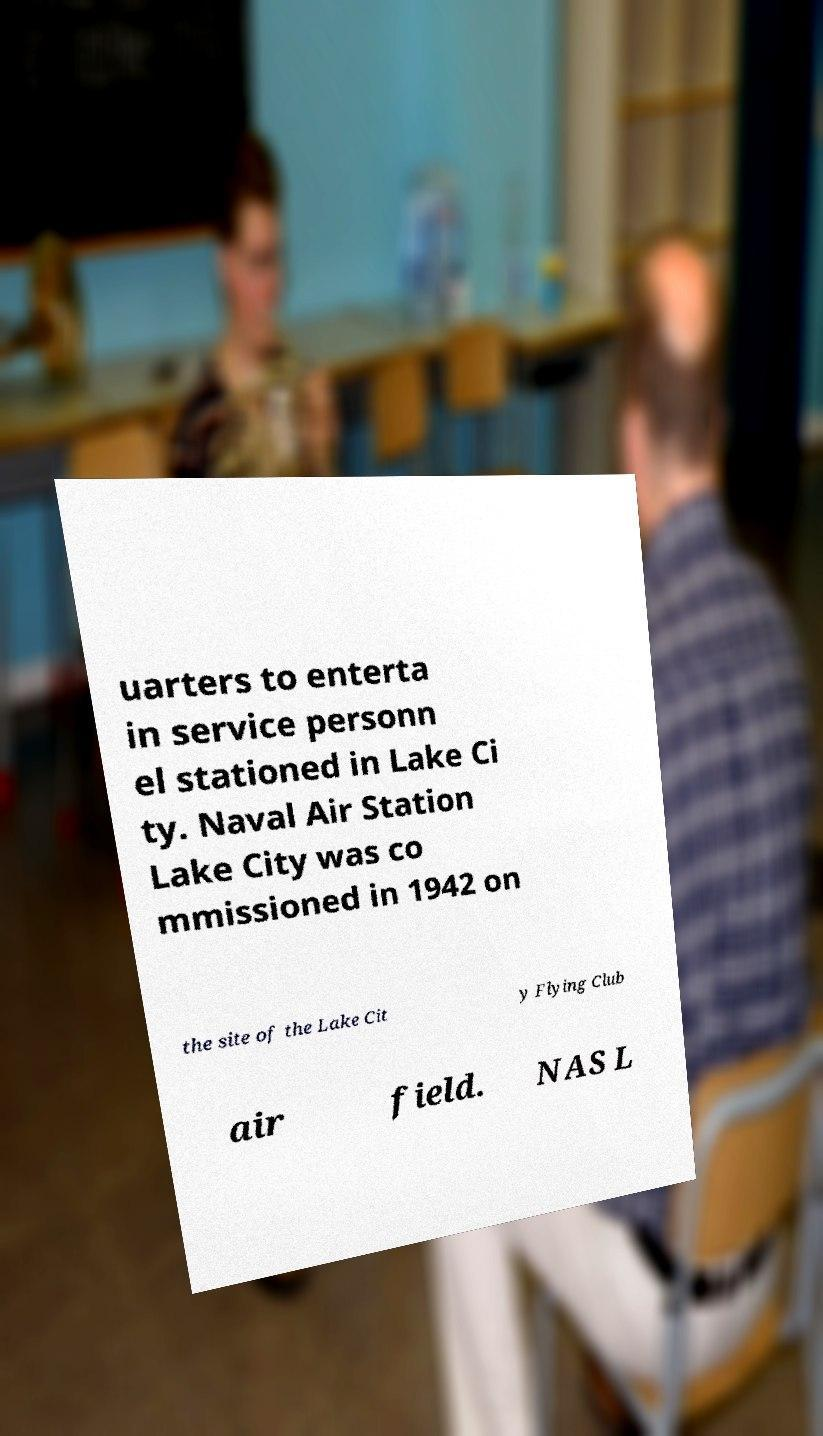I need the written content from this picture converted into text. Can you do that? uarters to enterta in service personn el stationed in Lake Ci ty. Naval Air Station Lake City was co mmissioned in 1942 on the site of the Lake Cit y Flying Club air field. NAS L 